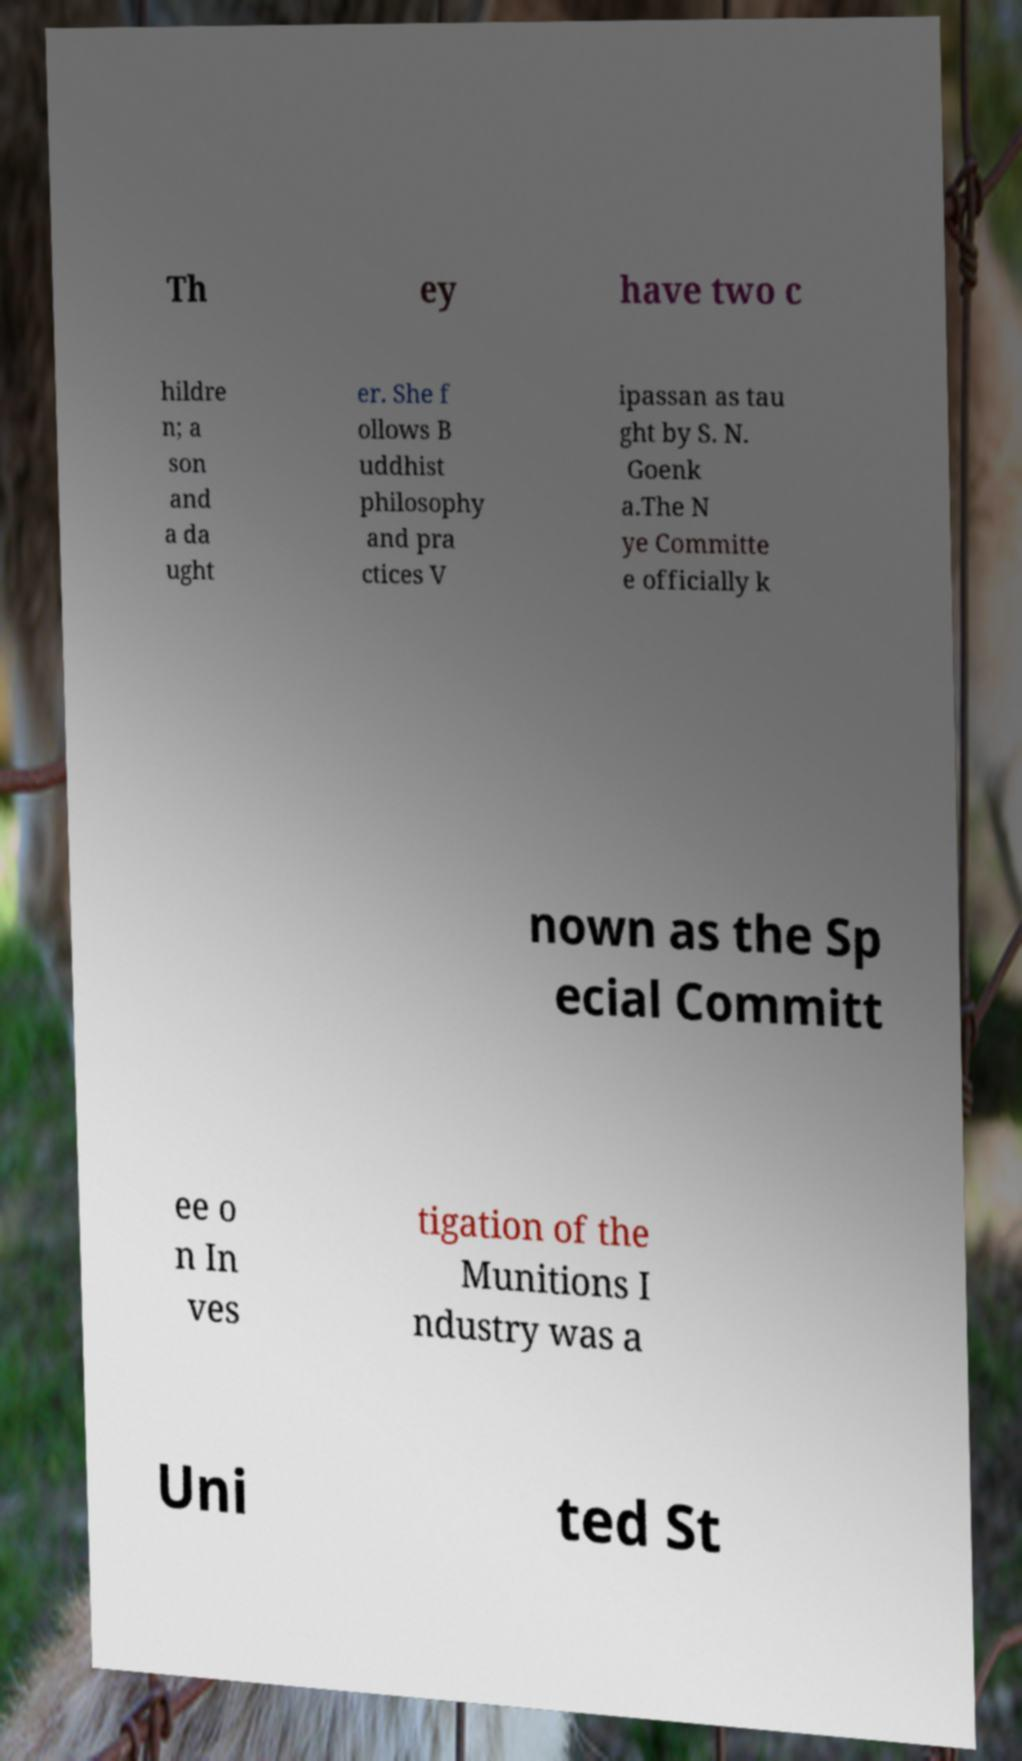For documentation purposes, I need the text within this image transcribed. Could you provide that? Th ey have two c hildre n; a son and a da ught er. She f ollows B uddhist philosophy and pra ctices V ipassan as tau ght by S. N. Goenk a.The N ye Committe e officially k nown as the Sp ecial Committ ee o n In ves tigation of the Munitions I ndustry was a Uni ted St 